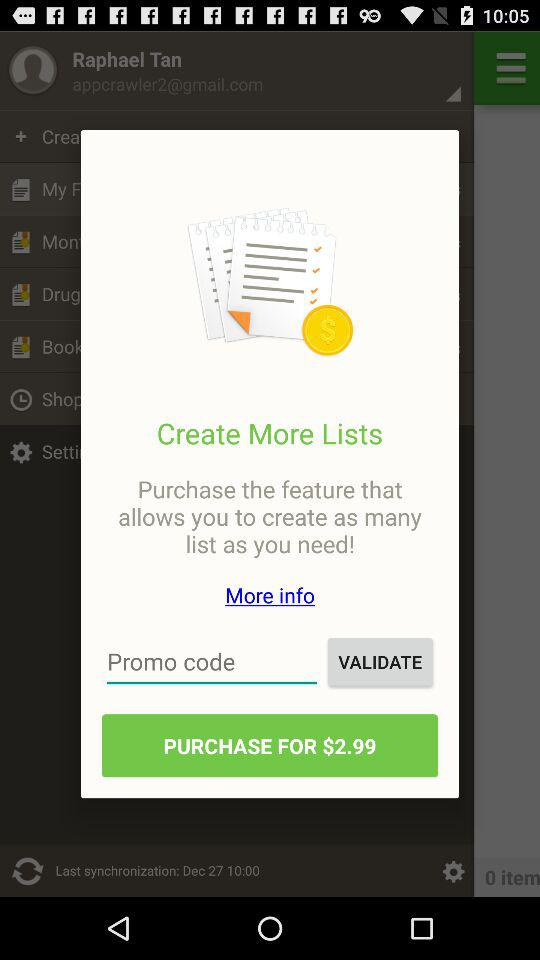What is the cost to purchase the feature? The cost is $2.99. 